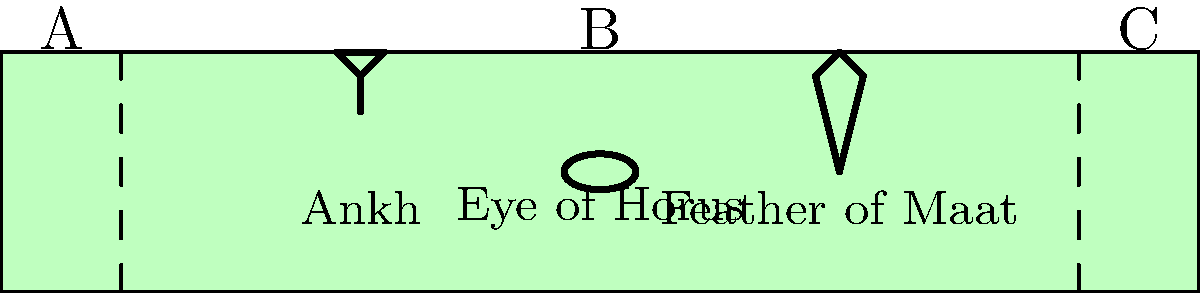In the given diagram of an Egyptian Book of the Dead papyrus scroll, three symbols are depicted: the Ankh, the Eye of Horus, and the Feather of Maat. If we divide the scroll into three equal sections (A, B, and C), which mathematical concept best describes the arrangement of these symbols in relation to the scroll's overall composition? To answer this question, let's analyze the layout of the symbols step-by-step:

1. The scroll is divided into three equal sections: A, B, and C.

2. We need to determine where each symbol is located:
   - The Ankh is in the left third (section A)
   - The Eye of Horus is in the middle third (section B)
   - The Feather of Maat is in the right third (section C)

3. This arrangement follows a specific mathematical concept:
   - Each symbol occupies its own distinct third of the scroll
   - The symbols are evenly distributed across the scroll's length
   - There is a sense of balance and symmetry in the composition

4. In mathematics and design, this type of arrangement is known as the "Rule of Thirds":
   - The Rule of Thirds divides an image into a 3x3 grid
   - Important elements are placed along these lines or at their intersections
   - This creates a balanced and aesthetically pleasing composition

5. In this case, the symbols are placed approximately at the vertical third lines and in the center of each horizontal third, adhering to the Rule of Thirds principle.

Therefore, the mathematical concept that best describes this arrangement is the Rule of Thirds, a principle commonly used in art and design for balanced compositions.
Answer: Rule of Thirds 